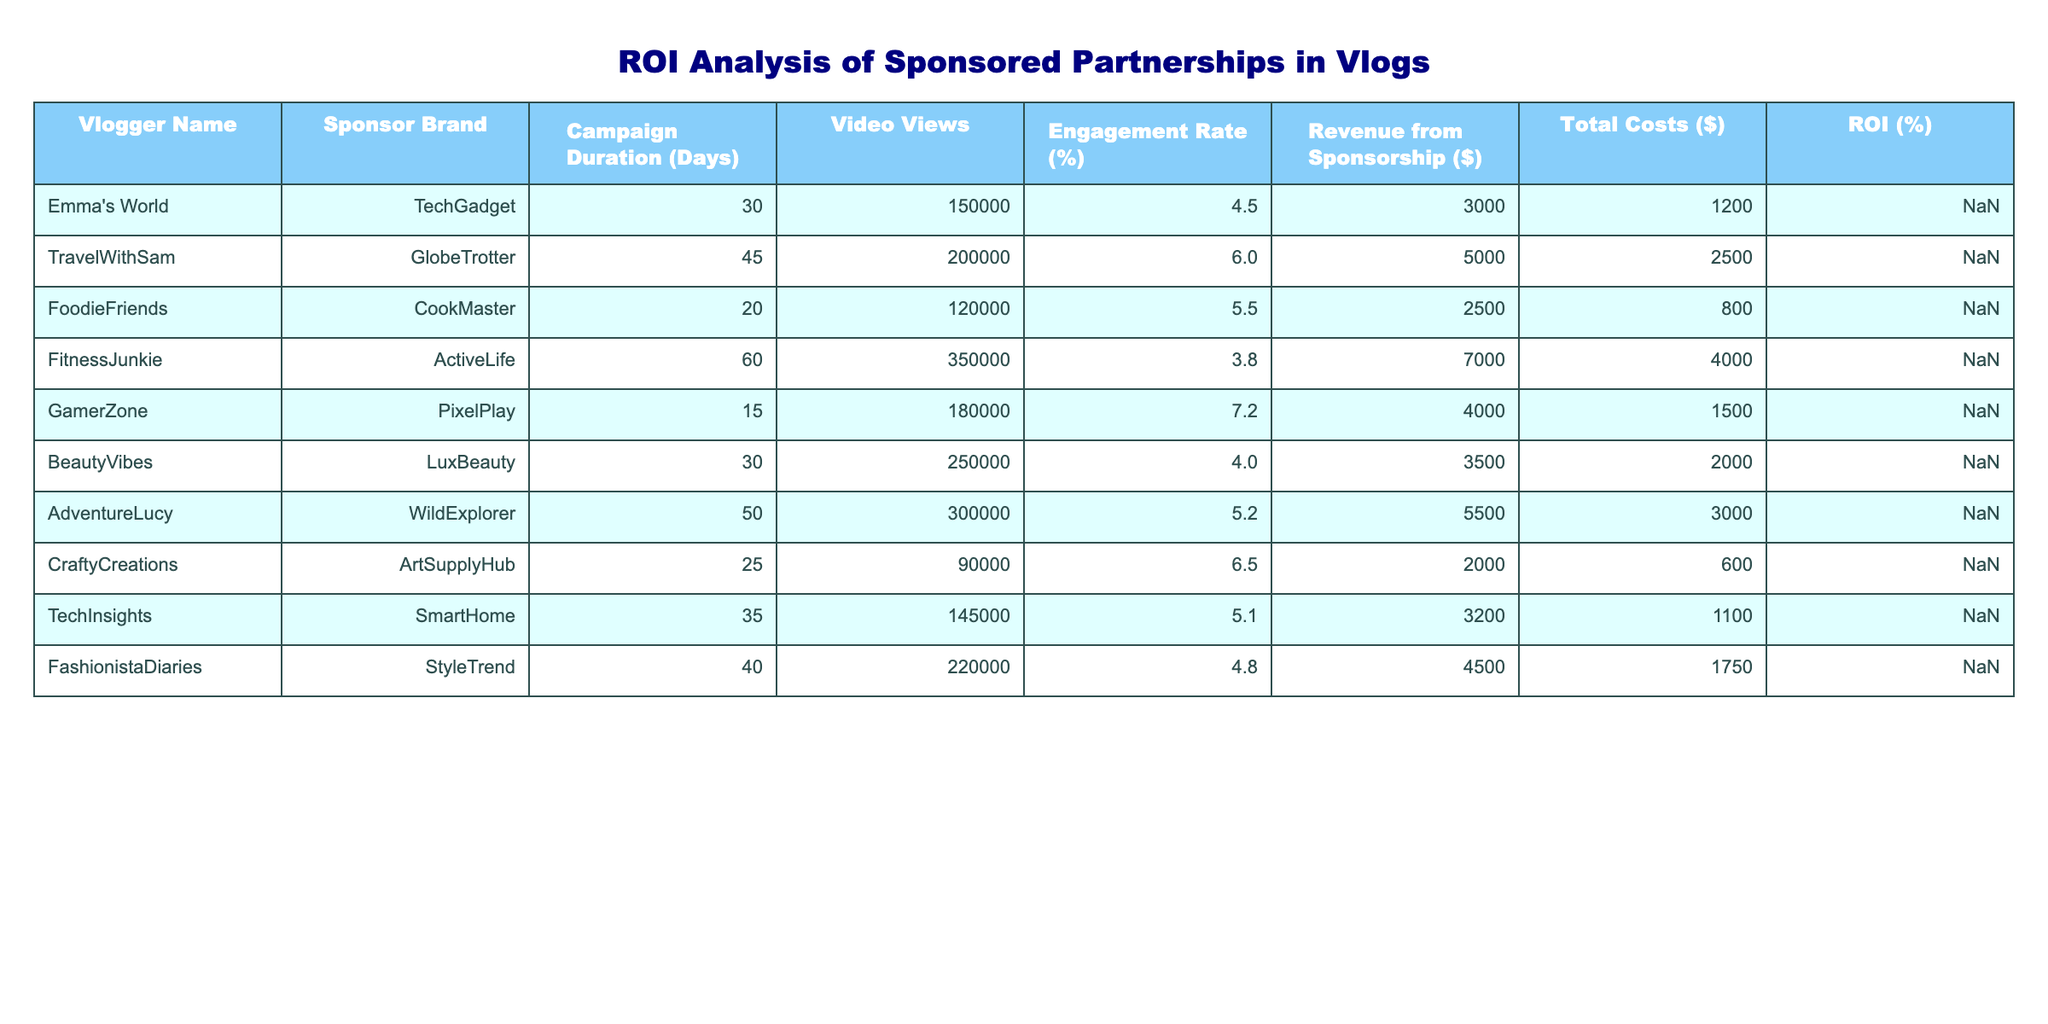What is the ROI for Emma's World with TechGadget? According to the table, the ROI for Emma's World is given directly as 150%.
Answer: 150% Which vlogger had the highest revenue from sponsorship? Examining the table, FitnessJunkie had the highest revenue from sponsorship at $7,000.
Answer: $7,000 What is the average engagement rate across all vloggers? To find the average engagement rate, sum all engagement rates (4.5 + 6.0 + 5.5 + 3.8 + 7.2 + 4.0 + 5.2 + 6.5 + 5.1 + 4.8) =  53.6 and divide by the number of vloggers (10), which gives 53.6/10 = 5.36%.
Answer: 5.36% Is the ROI for FoodieFriends greater than the average ROI of all vloggers? The ROI for FoodieFriends is 212.5%. To find the average ROI, sum all ROIs (150% + 100% + 212.5% + 75% + 166.67% + 75% + 83.33% + 233.33% + 190.91% + 157.14%) =  1,474.67%, and divide by 10, resulting in 147.47%. Since 212.5% is greater than 147.47%, the answer is yes.
Answer: Yes Which vlogger to return the least ROI? The table indicates that FitnessJunkie had the lowest ROI at 75%.
Answer: 75% What is the total sponsorship revenue generated by all vloggers? By summing the revenue from sponsorships (3000 + 5000 + 2500 + 7000 + 4000 + 3500 + 5500 + 2000 + 3200 + 4500) =  42,200.
Answer: $42,200 How many vloggers had an engagement rate of over 5%? By counting the entries with engagement rates higher than 5%, we see that there are 4 such vloggers (TravelWithSam, FoodieFriends, GamerZone, CraftyCreations).
Answer: 4 Which sponsorship generates the highest ROI and what is it? The table shows that CraftyCreations achieved the highest ROI of 233.33%.
Answer: CraftyCreations, 233.33% Is the revenue from TravelWithSam higher than the total costs? For TravelWithSam, the revenue from sponsorship is $5,000 and total costs are $2,500. Since 5,000 is greater than 2,500, the answer is yes.
Answer: Yes What is the total cost of all sponsorships combined? Summing the total costs (1200 + 2500 + 800 + 4000 + 1500 + 2000 + 3000 + 600 + 1100 + 1750) gives a total of 21,450.
Answer: $21,450 Which vlogger had the longest campaign duration and what was it? The longest campaign among the vloggers is 60 days for FitnessJunkie.
Answer: FitnessJunkie, 60 days 